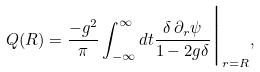Convert formula to latex. <formula><loc_0><loc_0><loc_500><loc_500>Q ( R ) = \frac { - g ^ { 2 } } { \pi } \int _ { - \infty } ^ { \infty } d t \frac { \delta \, \partial _ { r } \psi } { 1 - 2 g \delta } \Big | _ { r = R } ,</formula> 